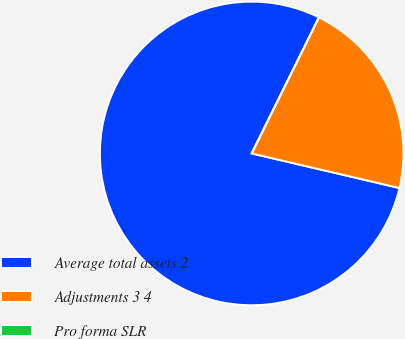Convert chart. <chart><loc_0><loc_0><loc_500><loc_500><pie_chart><fcel>Average total assets 2<fcel>Adjustments 3 4<fcel>Pro forma SLR<nl><fcel>78.65%<fcel>21.35%<fcel>0.0%<nl></chart> 